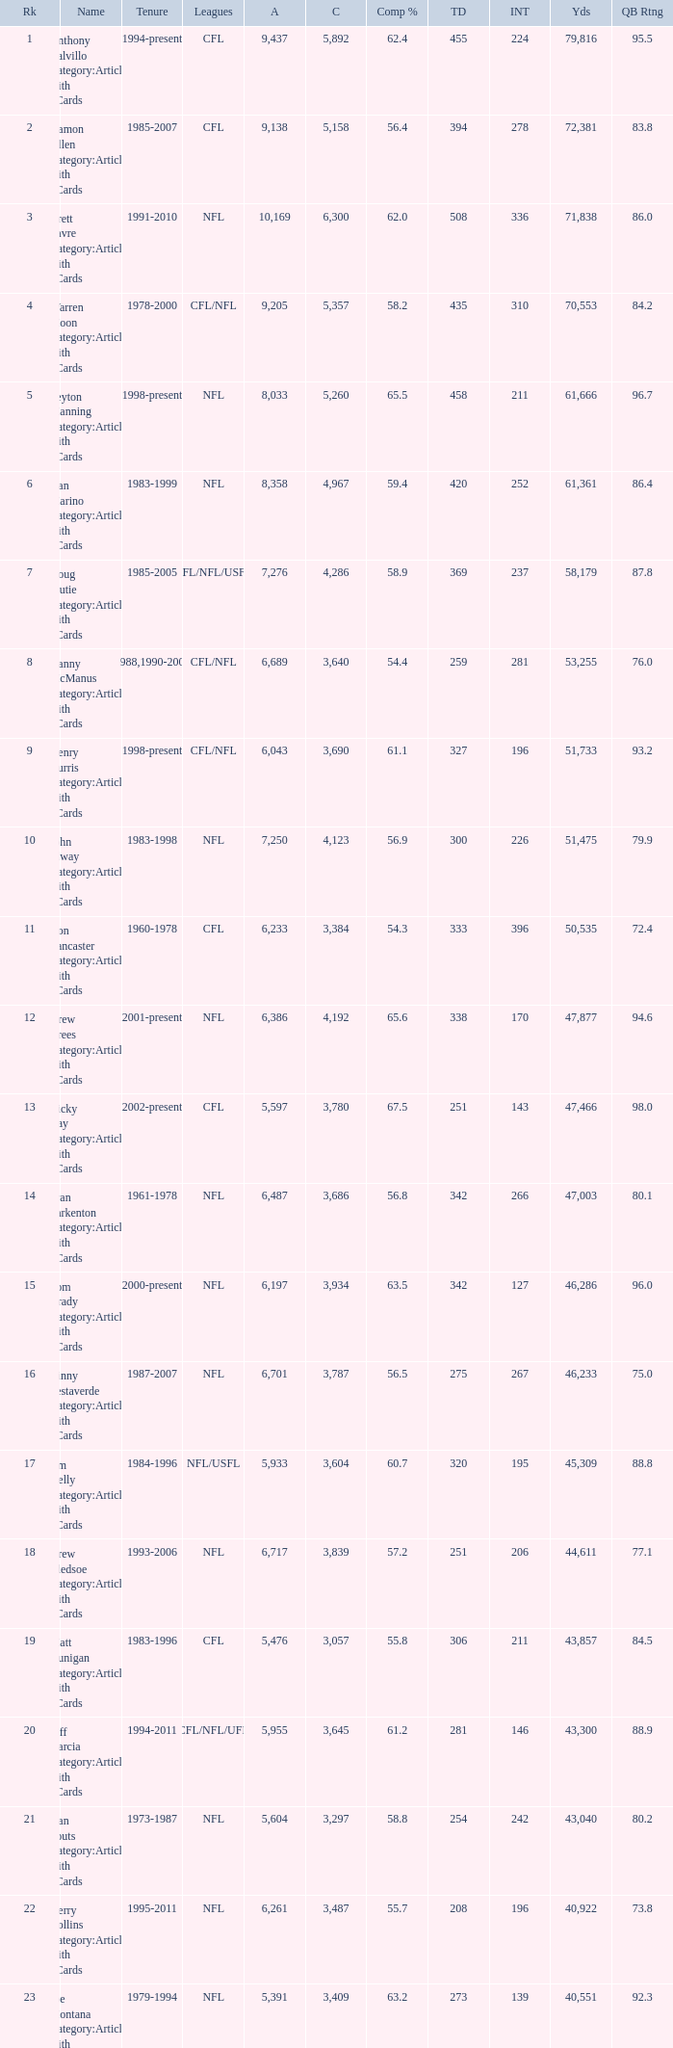What is the standing when there are more than 4,123 completions and the completion ratio is greater than 6 None. 